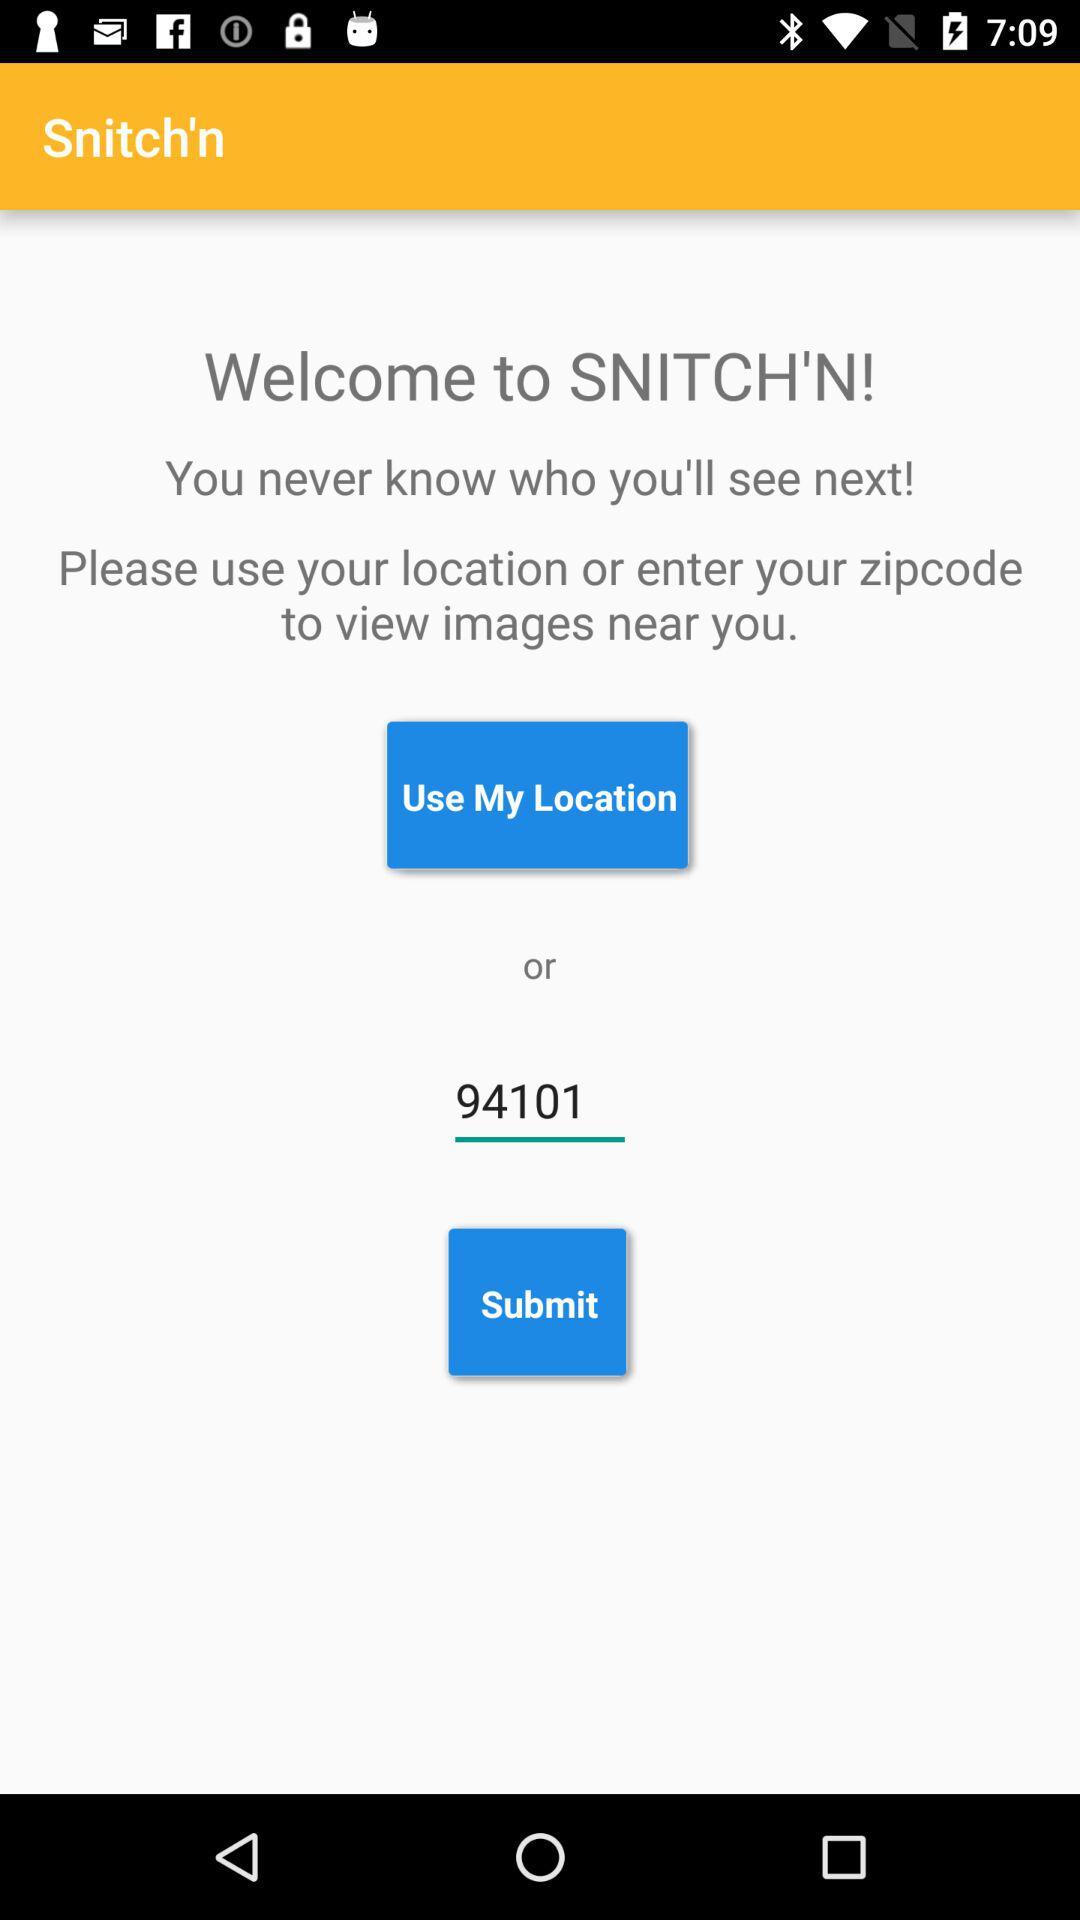What is the user's location?
When the provided information is insufficient, respond with <no answer>. <no answer> 